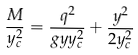Convert formula to latex. <formula><loc_0><loc_0><loc_500><loc_500>\frac { M } { y _ { c } ^ { 2 } } = \frac { q ^ { 2 } } { g y y _ { c } ^ { 2 } } + \frac { y ^ { 2 } } { 2 y _ { c } ^ { 2 } }</formula> 